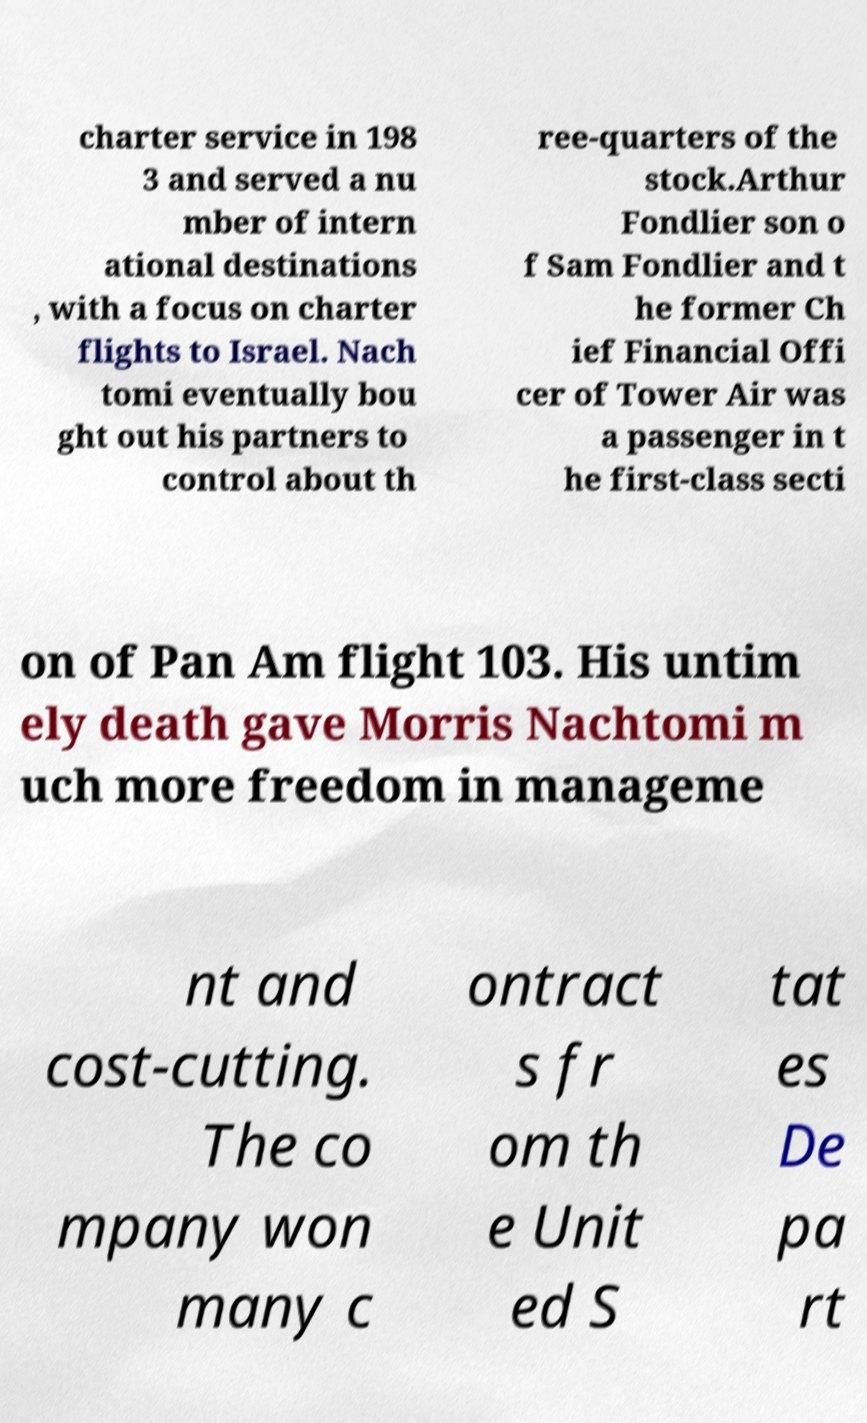Please identify and transcribe the text found in this image. charter service in 198 3 and served a nu mber of intern ational destinations , with a focus on charter flights to Israel. Nach tomi eventually bou ght out his partners to control about th ree-quarters of the stock.Arthur Fondlier son o f Sam Fondlier and t he former Ch ief Financial Offi cer of Tower Air was a passenger in t he first-class secti on of Pan Am flight 103. His untim ely death gave Morris Nachtomi m uch more freedom in manageme nt and cost-cutting. The co mpany won many c ontract s fr om th e Unit ed S tat es De pa rt 